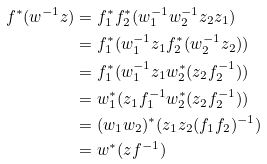<formula> <loc_0><loc_0><loc_500><loc_500>f ^ { \ast } ( w ^ { - 1 } z ) & = f _ { 1 } ^ { \ast } f _ { 2 } ^ { \ast } ( w _ { 1 } ^ { - 1 } w _ { 2 } ^ { - 1 } z _ { 2 } z _ { 1 } ) \\ & = f _ { 1 } ^ { \ast } ( w _ { 1 } ^ { - 1 } z _ { 1 } f _ { 2 } ^ { \ast } ( w _ { 2 } ^ { - 1 } z _ { 2 } ) ) \\ & = f _ { 1 } ^ { \ast } ( w _ { 1 } ^ { - 1 } z _ { 1 } w _ { 2 } ^ { \ast } ( z _ { 2 } f _ { 2 } ^ { - 1 } ) ) \\ & = w _ { 1 } ^ { \ast } ( z _ { 1 } f _ { 1 } ^ { - 1 } w _ { 2 } ^ { \ast } ( z _ { 2 } f _ { 2 } ^ { - 1 } ) ) \\ & = ( w _ { 1 } w _ { 2 } ) ^ { \ast } ( z _ { 1 } z _ { 2 } ( f _ { 1 } f _ { 2 } ) ^ { - 1 } ) \\ & = w ^ { \ast } ( z f ^ { - 1 } )</formula> 